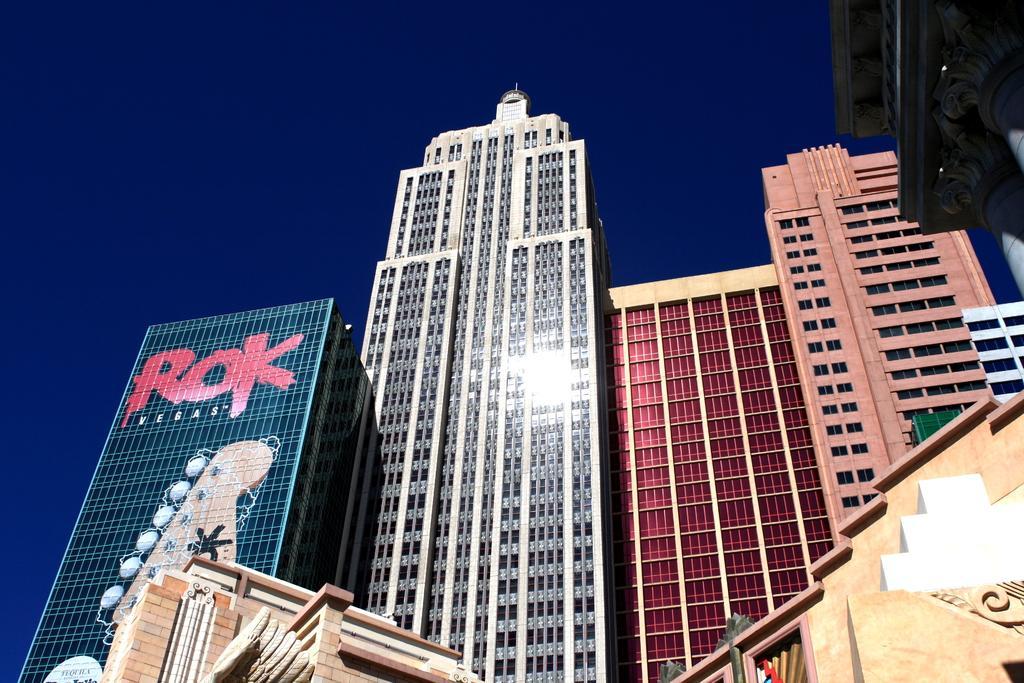Describe this image in one or two sentences. In this image we can see buildings at the top of the image there is sky. 